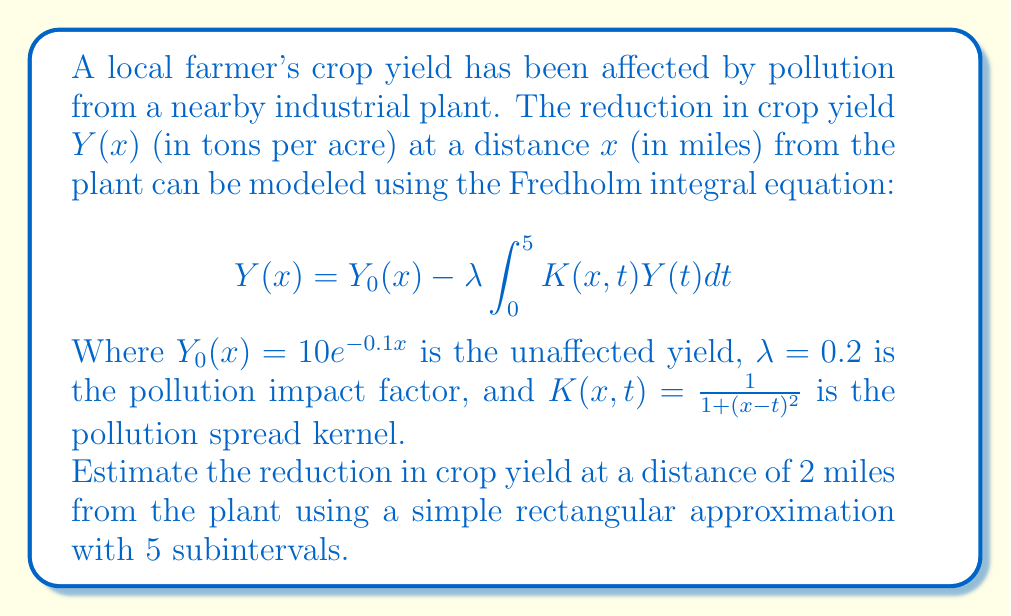Help me with this question. To solve this problem, we'll follow these steps:

1) First, we need to discretize the integral using the rectangular approximation with 5 subintervals. The interval [0, 5] will be divided into 5 equal parts, each of width $\Delta t = 1$ mile.

2) The midpoints of these subintervals will be at $t = 0.5, 1.5, 2.5, 3.5, 4.5$ miles.

3) The rectangular approximation of the integral is:

   $$\int_0^5 K(x,t)Y(t)dt \approx \sum_{i=1}^5 K(x,t_i)Y(t_i)\Delta t$$

   where $t_i$ are the midpoints and $\Delta t = 1$.

4) We don't know $Y(t_i)$ yet, so we'll use $Y_0(t_i)$ as an initial approximation:

   $Y_0(0.5) = 10e^{-0.05} \approx 9.51$
   $Y_0(1.5) = 10e^{-0.15} \approx 8.61$
   $Y_0(2.5) = 10e^{-0.25} \approx 7.79$
   $Y_0(3.5) = 10e^{-0.35} \approx 7.05$
   $Y_0(4.5) = 10e^{-0.45} \approx 6.38$

5) Now, we can calculate $K(2,t_i)$:

   $K(2,0.5) = \frac{1}{1+(2-0.5)^2} = \frac{1}{3.25} \approx 0.308$
   $K(2,1.5) = \frac{1}{1+(2-1.5)^2} = \frac{1}{1.25} = 0.800$
   $K(2,2.5) = \frac{1}{1+(2-2.5)^2} = \frac{1}{1.25} = 0.800$
   $K(2,3.5) = \frac{1}{1+(2-3.5)^2} = \frac{1}{3.25} \approx 0.308$
   $K(2,4.5) = \frac{1}{1+(2-4.5)^2} = \frac{1}{7.25} \approx 0.138$

6) We can now approximate the integral:

   $$\int_0^5 K(2,t)Y(t)dt \approx 0.308(9.51) + 0.800(8.61) + 0.800(7.79) + 0.308(7.05) + 0.138(6.38) \approx 18.75$$

7) The unaffected yield at 2 miles is $Y_0(2) = 10e^{-0.2} \approx 8.19$

8) Finally, we can calculate $Y(2)$:

   $$Y(2) = Y_0(2) - \lambda \int_0^5 K(2,t)Y(t)dt \approx 8.19 - 0.2(18.75) = 8.19 - 3.75 = 4.44$$

9) The reduction in crop yield is therefore:

   $$Y_0(2) - Y(2) = 8.19 - 4.44 = 3.75$$ tons per acre.
Answer: 3.75 tons per acre 